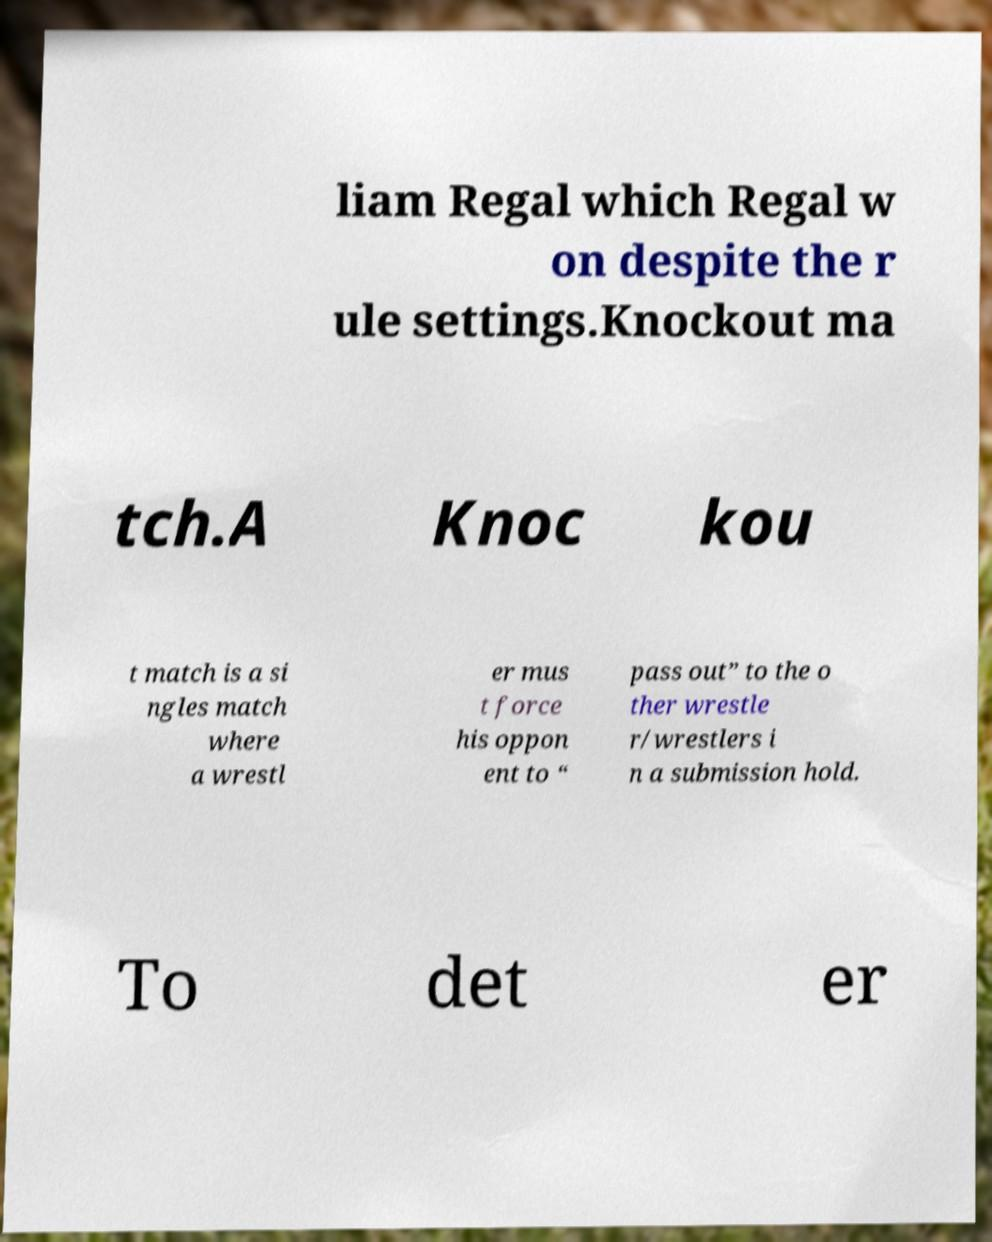I need the written content from this picture converted into text. Can you do that? liam Regal which Regal w on despite the r ule settings.Knockout ma tch.A Knoc kou t match is a si ngles match where a wrestl er mus t force his oppon ent to “ pass out” to the o ther wrestle r/wrestlers i n a submission hold. To det er 